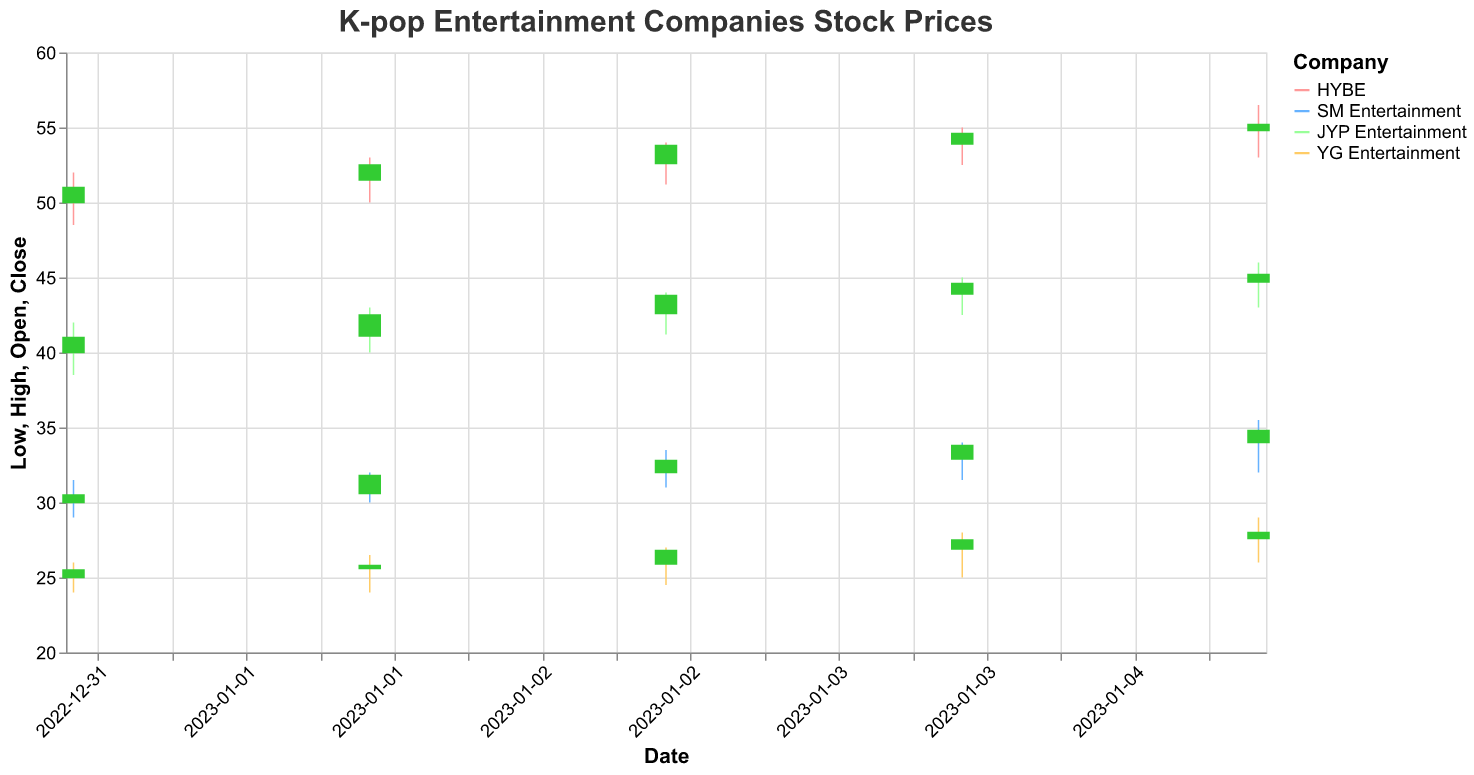What event corresponds to the highest closing price for HYBE? The highest closing price for HYBE is observed on January 5th which corresponds to the event "Rumors of BTS Member Solo Debut"
Answer: Rumors of BTS Member Solo Debut How did the announcement of the new BTS album impact HYBE's stock price on January 1st? On January 1st, the "New BTS Album Announcement" led to an increase in HYBE's closing price from its opening at 50.00 to its closing at 51.00. The candlestick shows that the stock price generally increased
Answer: Increased from 50.00 to 51.00 Which company's stock had the highest volume on January 3rd? By inspecting the volumes of each company on January 3rd, HYBE had a volume of 7,100,000, which is the highest compared to the volumes of SM Entertainment, JYP Entertainment, and YG Entertainment
Answer: HYBE Compare the stock price reaction to the New Album Announcements for BTS, EXO, TWICE, and BLACKPINK. Which company saw the greatest increase in closing price on January 1st? For January 1st, the closing prices are: HYBE (51.00), SM Entertainment (30.50), JYP Entertainment (41.00), and YG Entertainment (25.50). With opening prices of: HYBE (50.00), SM Entertainment (30.00), JYP Entertainment (40.00), and YG Entertainment (25.00). Calculating the differences: HYBE (+1.00), SM Entertainment (+0.50), JYP Entertainment (+1.00), YG Entertainment (+0.50). So, both HYBE and JYP Entertainment saw the greatest increase in closing price
Answer: HYBE and JYP Entertainment What was the highest price reached by JYP Entertainment's stock during the observed period? The highest price shown on the plot for JYP Entertainment was reached on January 5th with the high reaching 46.00
Answer: 46.00 How did the stock price of SM Entertainment change in response to The EXO Wins Award at Music Awards? On January 4th, in response to "EXO Wins Award at Music Awards", the open price was 32.90 and the close price was 33.80, indicating an increase. The high price that day reached 34.00 and the low was 31.50
Answer: Increased from 32.90 to 33.80 Which company's stock experienced the largest price range on any given day, and what was the event on that day? By comparing the highest range (high - low) for each company on each day, HYBE on January 5th had the largest range (56.50 - 53.00 = 3.50) during the event "Rumors of BTS Member Solo Debut"
Answer: HYBE on January 5th, during Rumors of BTS Member Solo Debut Find the average closing price for YG Entertainment during the observed period. Summing up the closing prices for YG Entertainment (25.50, 25.80, 26.80, 27.50, 28.00) gives 133.60. Dividing by the number of days (5) gives the average closing price as 26.72
Answer: 26.72 